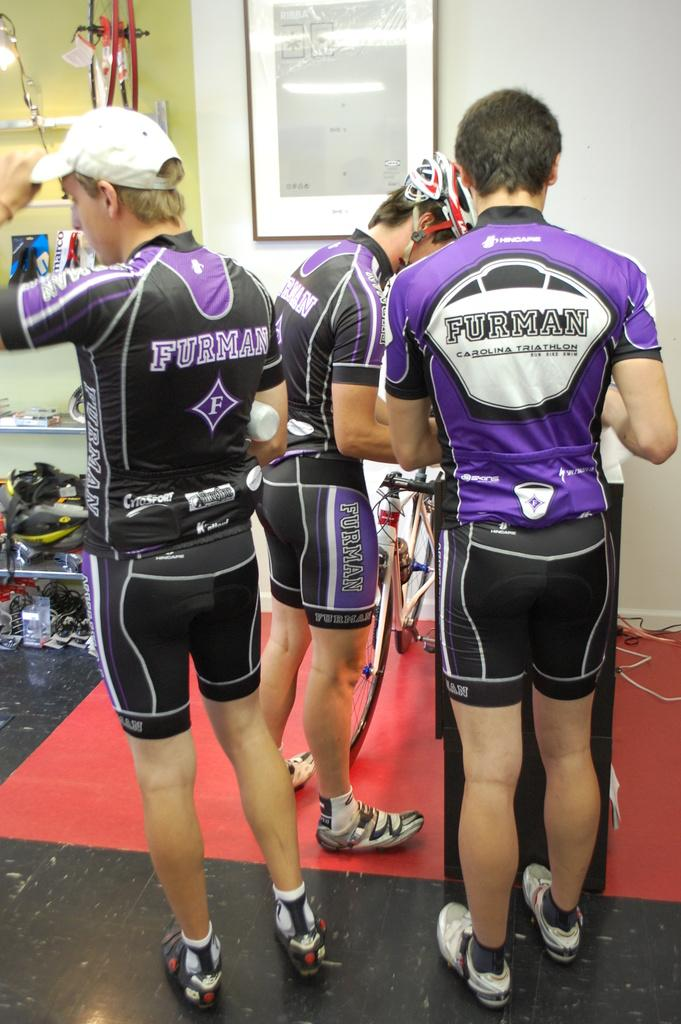Provide a one-sentence caption for the provided image. Three athletic bicycle racers with Furman wear on. 